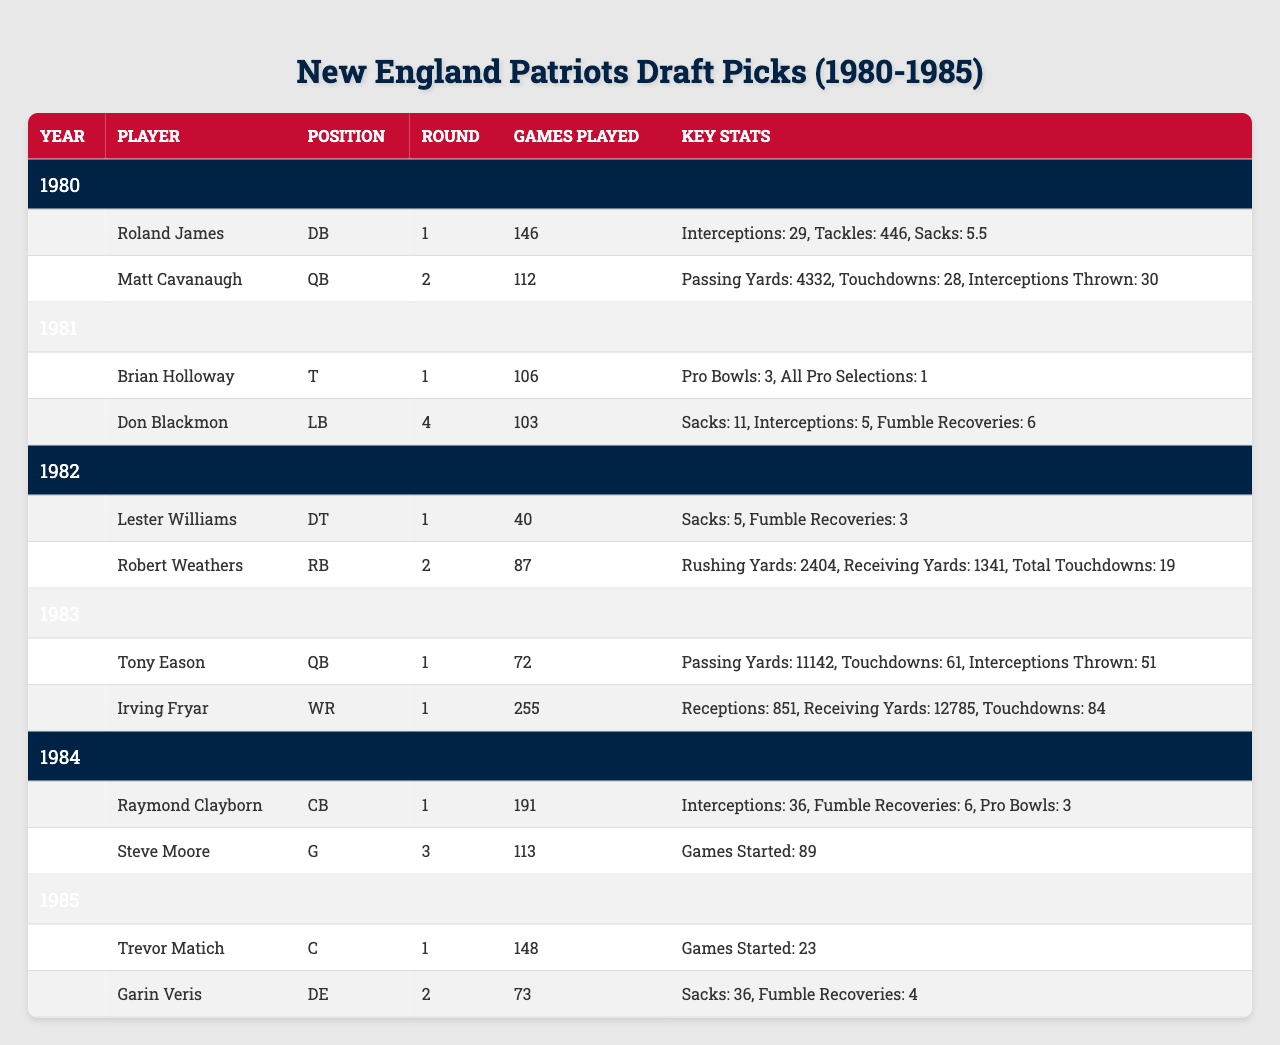What player had the most interceptions in their career? In the table, the player with the most interceptions is Roland James with 29 interceptions.
Answer: Roland James How many games did Irving Fryar play in his career? The table shows that Irving Fryar played a total of 255 games during his career.
Answer: 255 games Which player had the highest number of total touchdowns? Robert Weathers had 19 total touchdowns, which is the highest among the listed players in the table.
Answer: Robert Weathers What is the total number of games played by players drafted in 1983? The total number of games played by players in that draft is 72 (Tony Eason) + 255 (Irving Fryar) = 327.
Answer: 327 Did any of the 1981 draft picks have at least one Pro Bowl selection? Yes, Brian Holloway had 3 Pro Bowl selections, confirmed in the table.
Answer: Yes Which position did Matt Cavanaugh play and how many touchdowns did he throw? Matt Cavanaugh was a QB and he threw 28 touchdowns as shown in the table.
Answer: QB, 28 touchdowns What is the average number of games played by all players drafted in 1980? The total number of games played by 1980 draft picks is 146 (Roland James) + 112 (Matt Cavanaugh) = 258. The average is 258 / 2 = 129.
Answer: 129 games Which player from the 1984 draft was selected in the first round and how many fumble recoveries did he have? The table indicates that Raymond Clayborn was selected in the first round and he had 6 fumble recoveries.
Answer: Raymond Clayborn, 6 fumble recoveries How many interceptions did Don Blackmon have compared to Raymond Clayborn? Don Blackmon had 5 interceptions, while Raymond Clayborn had 36 interceptions. Thus, Clayborn had 31 more interceptions than Blackmon.
Answer: Clayborn had 31 more interceptions Is Trevor Matich still active in the NFL based on the data provided? The table does not provide any indication of current activity; hence we cannot determine if he is still active.
Answer: No information available In total, how many Pro Bowl selections did players from the 1981 and 1984 drafts combine for? The total is 3 (Brian Holloway from 1981) + 3 (Raymond Clayborn from 1984) = 6 Pro Bowls.
Answer: 6 Pro Bowl selections 